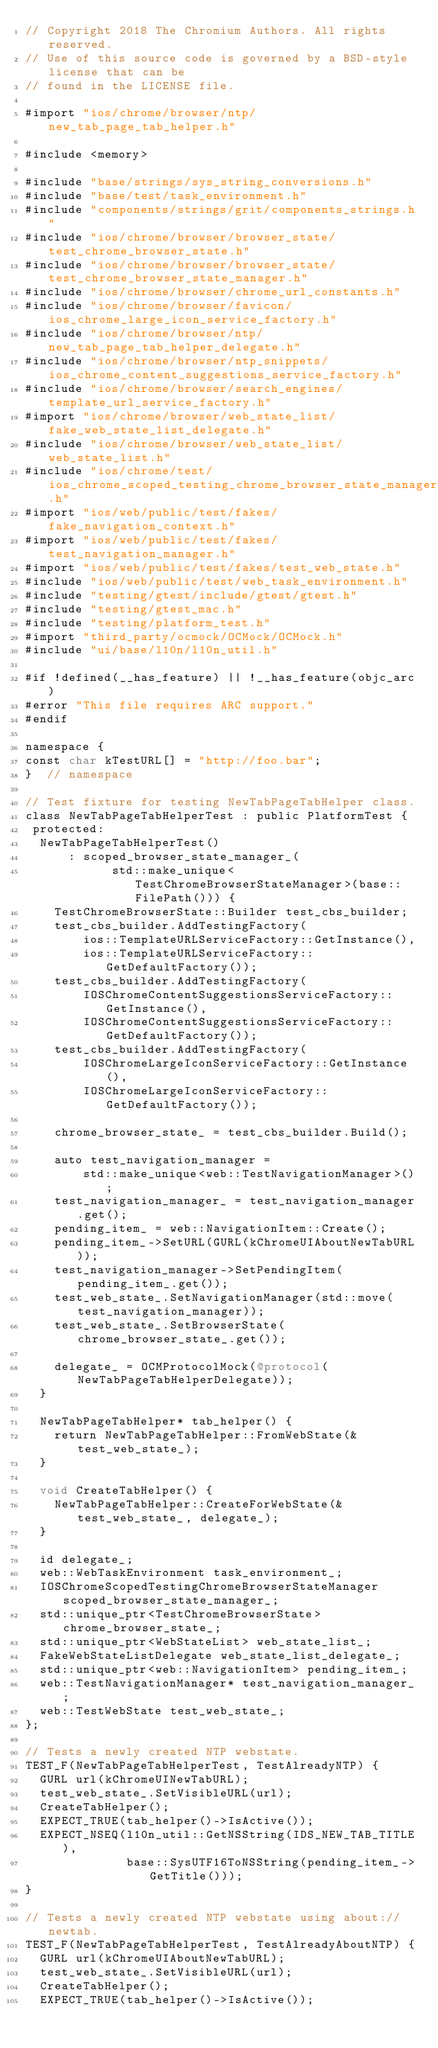<code> <loc_0><loc_0><loc_500><loc_500><_ObjectiveC_>// Copyright 2018 The Chromium Authors. All rights reserved.
// Use of this source code is governed by a BSD-style license that can be
// found in the LICENSE file.

#import "ios/chrome/browser/ntp/new_tab_page_tab_helper.h"

#include <memory>

#include "base/strings/sys_string_conversions.h"
#include "base/test/task_environment.h"
#include "components/strings/grit/components_strings.h"
#include "ios/chrome/browser/browser_state/test_chrome_browser_state.h"
#include "ios/chrome/browser/browser_state/test_chrome_browser_state_manager.h"
#include "ios/chrome/browser/chrome_url_constants.h"
#include "ios/chrome/browser/favicon/ios_chrome_large_icon_service_factory.h"
#include "ios/chrome/browser/ntp/new_tab_page_tab_helper_delegate.h"
#include "ios/chrome/browser/ntp_snippets/ios_chrome_content_suggestions_service_factory.h"
#include "ios/chrome/browser/search_engines/template_url_service_factory.h"
#import "ios/chrome/browser/web_state_list/fake_web_state_list_delegate.h"
#include "ios/chrome/browser/web_state_list/web_state_list.h"
#include "ios/chrome/test/ios_chrome_scoped_testing_chrome_browser_state_manager.h"
#import "ios/web/public/test/fakes/fake_navigation_context.h"
#import "ios/web/public/test/fakes/test_navigation_manager.h"
#import "ios/web/public/test/fakes/test_web_state.h"
#include "ios/web/public/test/web_task_environment.h"
#include "testing/gtest/include/gtest/gtest.h"
#include "testing/gtest_mac.h"
#include "testing/platform_test.h"
#import "third_party/ocmock/OCMock/OCMock.h"
#include "ui/base/l10n/l10n_util.h"

#if !defined(__has_feature) || !__has_feature(objc_arc)
#error "This file requires ARC support."
#endif

namespace {
const char kTestURL[] = "http://foo.bar";
}  // namespace

// Test fixture for testing NewTabPageTabHelper class.
class NewTabPageTabHelperTest : public PlatformTest {
 protected:
  NewTabPageTabHelperTest()
      : scoped_browser_state_manager_(
            std::make_unique<TestChromeBrowserStateManager>(base::FilePath())) {
    TestChromeBrowserState::Builder test_cbs_builder;
    test_cbs_builder.AddTestingFactory(
        ios::TemplateURLServiceFactory::GetInstance(),
        ios::TemplateURLServiceFactory::GetDefaultFactory());
    test_cbs_builder.AddTestingFactory(
        IOSChromeContentSuggestionsServiceFactory::GetInstance(),
        IOSChromeContentSuggestionsServiceFactory::GetDefaultFactory());
    test_cbs_builder.AddTestingFactory(
        IOSChromeLargeIconServiceFactory::GetInstance(),
        IOSChromeLargeIconServiceFactory::GetDefaultFactory());

    chrome_browser_state_ = test_cbs_builder.Build();

    auto test_navigation_manager =
        std::make_unique<web::TestNavigationManager>();
    test_navigation_manager_ = test_navigation_manager.get();
    pending_item_ = web::NavigationItem::Create();
    pending_item_->SetURL(GURL(kChromeUIAboutNewTabURL));
    test_navigation_manager->SetPendingItem(pending_item_.get());
    test_web_state_.SetNavigationManager(std::move(test_navigation_manager));
    test_web_state_.SetBrowserState(chrome_browser_state_.get());

    delegate_ = OCMProtocolMock(@protocol(NewTabPageTabHelperDelegate));
  }

  NewTabPageTabHelper* tab_helper() {
    return NewTabPageTabHelper::FromWebState(&test_web_state_);
  }

  void CreateTabHelper() {
    NewTabPageTabHelper::CreateForWebState(&test_web_state_, delegate_);
  }

  id delegate_;
  web::WebTaskEnvironment task_environment_;
  IOSChromeScopedTestingChromeBrowserStateManager scoped_browser_state_manager_;
  std::unique_ptr<TestChromeBrowserState> chrome_browser_state_;
  std::unique_ptr<WebStateList> web_state_list_;
  FakeWebStateListDelegate web_state_list_delegate_;
  std::unique_ptr<web::NavigationItem> pending_item_;
  web::TestNavigationManager* test_navigation_manager_;
  web::TestWebState test_web_state_;
};

// Tests a newly created NTP webstate.
TEST_F(NewTabPageTabHelperTest, TestAlreadyNTP) {
  GURL url(kChromeUINewTabURL);
  test_web_state_.SetVisibleURL(url);
  CreateTabHelper();
  EXPECT_TRUE(tab_helper()->IsActive());
  EXPECT_NSEQ(l10n_util::GetNSString(IDS_NEW_TAB_TITLE),
              base::SysUTF16ToNSString(pending_item_->GetTitle()));
}

// Tests a newly created NTP webstate using about://newtab.
TEST_F(NewTabPageTabHelperTest, TestAlreadyAboutNTP) {
  GURL url(kChromeUIAboutNewTabURL);
  test_web_state_.SetVisibleURL(url);
  CreateTabHelper();
  EXPECT_TRUE(tab_helper()->IsActive());</code> 